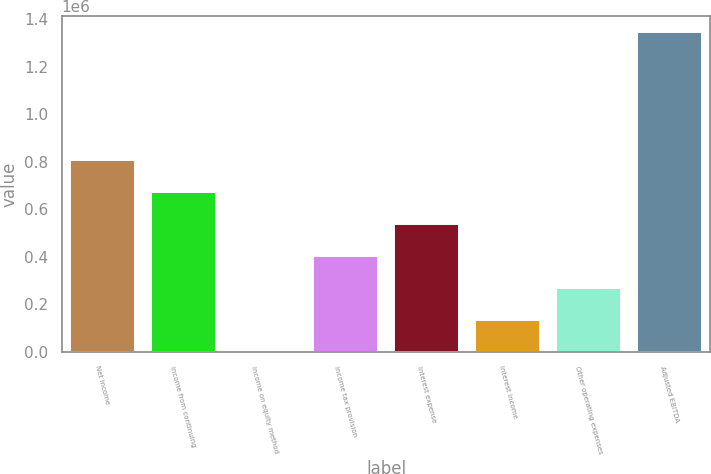Convert chart. <chart><loc_0><loc_0><loc_500><loc_500><bar_chart><fcel>Net income<fcel>Income from continuing<fcel>Income on equity method<fcel>Income tax provision<fcel>Interest expense<fcel>Interest income<fcel>Other operating expenses<fcel>Adjusted EBITDA<nl><fcel>808664<fcel>673894<fcel>40<fcel>404352<fcel>539123<fcel>134811<fcel>269581<fcel>1.34775e+06<nl></chart> 